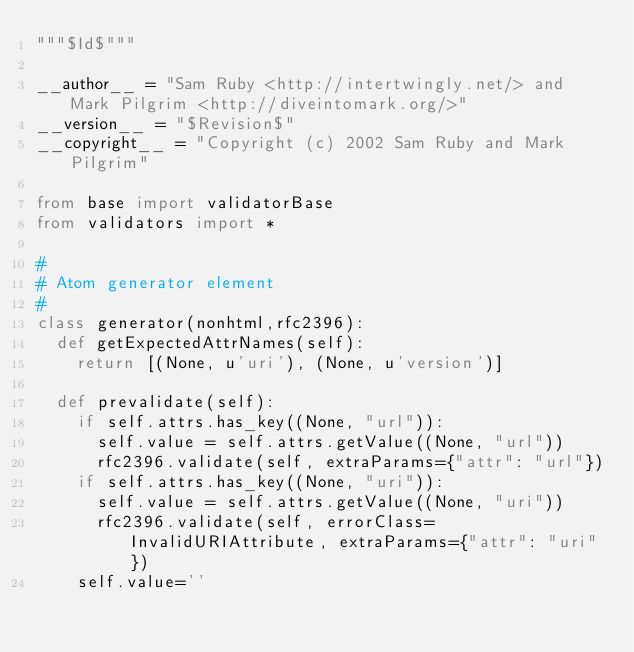<code> <loc_0><loc_0><loc_500><loc_500><_Python_>"""$Id$"""

__author__ = "Sam Ruby <http://intertwingly.net/> and Mark Pilgrim <http://diveintomark.org/>"
__version__ = "$Revision$"
__copyright__ = "Copyright (c) 2002 Sam Ruby and Mark Pilgrim"

from base import validatorBase
from validators import *

#
# Atom generator element
#
class generator(nonhtml,rfc2396):
  def getExpectedAttrNames(self):
    return [(None, u'uri'), (None, u'version')]

  def prevalidate(self):
    if self.attrs.has_key((None, "url")):
      self.value = self.attrs.getValue((None, "url"))
      rfc2396.validate(self, extraParams={"attr": "url"})
    if self.attrs.has_key((None, "uri")):
      self.value = self.attrs.getValue((None, "uri"))
      rfc2396.validate(self, errorClass=InvalidURIAttribute, extraParams={"attr": "uri"})
    self.value=''
</code> 